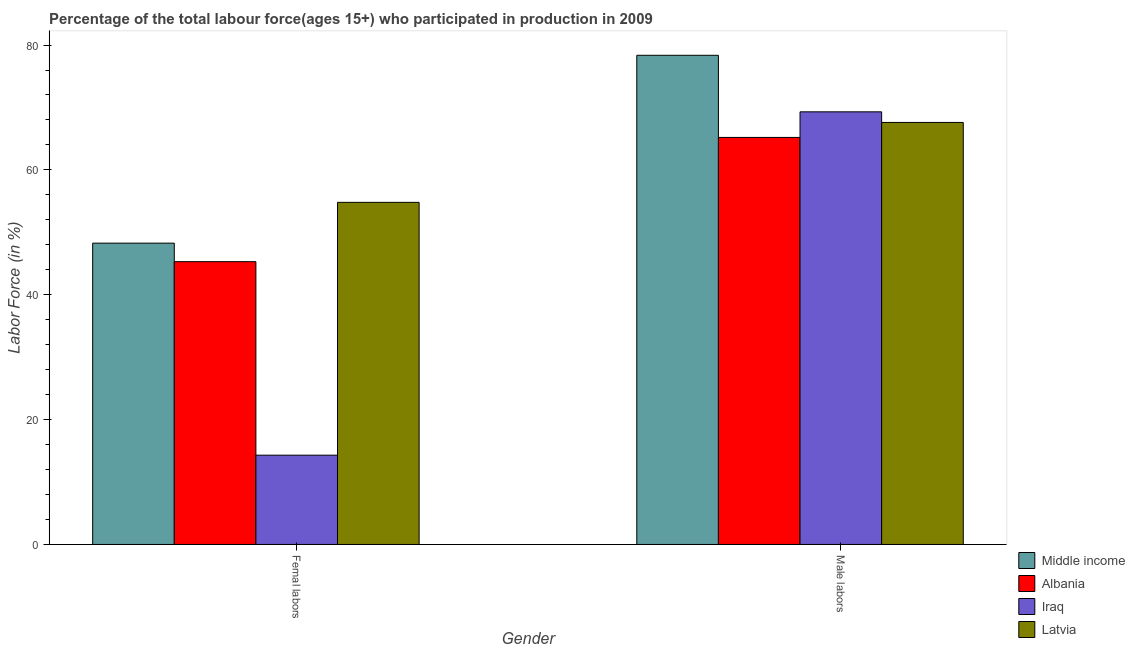How many groups of bars are there?
Give a very brief answer. 2. Are the number of bars per tick equal to the number of legend labels?
Your response must be concise. Yes. Are the number of bars on each tick of the X-axis equal?
Ensure brevity in your answer.  Yes. How many bars are there on the 2nd tick from the left?
Your answer should be very brief. 4. What is the label of the 1st group of bars from the left?
Provide a succinct answer. Femal labors. What is the percentage of female labor force in Albania?
Your answer should be compact. 45.3. Across all countries, what is the maximum percentage of female labor force?
Your response must be concise. 54.8. Across all countries, what is the minimum percentage of female labor force?
Your answer should be compact. 14.3. In which country was the percentage of female labor force maximum?
Provide a succinct answer. Latvia. In which country was the percentage of male labour force minimum?
Your response must be concise. Albania. What is the total percentage of female labor force in the graph?
Your response must be concise. 162.67. What is the difference between the percentage of male labour force in Albania and the percentage of female labor force in Iraq?
Provide a short and direct response. 50.9. What is the average percentage of female labor force per country?
Your answer should be compact. 40.67. What is the difference between the percentage of male labour force and percentage of female labor force in Latvia?
Offer a very short reply. 12.8. What is the ratio of the percentage of male labour force in Albania to that in Latvia?
Keep it short and to the point. 0.96. Is the percentage of male labour force in Albania less than that in Iraq?
Offer a very short reply. Yes. In how many countries, is the percentage of female labor force greater than the average percentage of female labor force taken over all countries?
Offer a terse response. 3. What does the 2nd bar from the left in Femal labors represents?
Offer a terse response. Albania. What does the 2nd bar from the right in Male labors represents?
Offer a very short reply. Iraq. How many bars are there?
Make the answer very short. 8. Does the graph contain grids?
Your answer should be compact. No. What is the title of the graph?
Provide a succinct answer. Percentage of the total labour force(ages 15+) who participated in production in 2009. What is the label or title of the X-axis?
Make the answer very short. Gender. What is the Labor Force (in %) in Middle income in Femal labors?
Your response must be concise. 48.27. What is the Labor Force (in %) of Albania in Femal labors?
Your answer should be very brief. 45.3. What is the Labor Force (in %) in Iraq in Femal labors?
Provide a short and direct response. 14.3. What is the Labor Force (in %) in Latvia in Femal labors?
Offer a very short reply. 54.8. What is the Labor Force (in %) in Middle income in Male labors?
Make the answer very short. 78.36. What is the Labor Force (in %) of Albania in Male labors?
Ensure brevity in your answer.  65.2. What is the Labor Force (in %) of Iraq in Male labors?
Make the answer very short. 69.3. What is the Labor Force (in %) of Latvia in Male labors?
Provide a succinct answer. 67.6. Across all Gender, what is the maximum Labor Force (in %) of Middle income?
Give a very brief answer. 78.36. Across all Gender, what is the maximum Labor Force (in %) of Albania?
Your answer should be compact. 65.2. Across all Gender, what is the maximum Labor Force (in %) in Iraq?
Your answer should be very brief. 69.3. Across all Gender, what is the maximum Labor Force (in %) of Latvia?
Keep it short and to the point. 67.6. Across all Gender, what is the minimum Labor Force (in %) in Middle income?
Offer a terse response. 48.27. Across all Gender, what is the minimum Labor Force (in %) of Albania?
Your response must be concise. 45.3. Across all Gender, what is the minimum Labor Force (in %) of Iraq?
Your answer should be very brief. 14.3. Across all Gender, what is the minimum Labor Force (in %) of Latvia?
Your answer should be compact. 54.8. What is the total Labor Force (in %) in Middle income in the graph?
Your answer should be very brief. 126.63. What is the total Labor Force (in %) of Albania in the graph?
Offer a terse response. 110.5. What is the total Labor Force (in %) of Iraq in the graph?
Your answer should be compact. 83.6. What is the total Labor Force (in %) of Latvia in the graph?
Keep it short and to the point. 122.4. What is the difference between the Labor Force (in %) in Middle income in Femal labors and that in Male labors?
Your answer should be compact. -30.09. What is the difference between the Labor Force (in %) of Albania in Femal labors and that in Male labors?
Your answer should be compact. -19.9. What is the difference between the Labor Force (in %) of Iraq in Femal labors and that in Male labors?
Ensure brevity in your answer.  -55. What is the difference between the Labor Force (in %) in Middle income in Femal labors and the Labor Force (in %) in Albania in Male labors?
Provide a succinct answer. -16.93. What is the difference between the Labor Force (in %) of Middle income in Femal labors and the Labor Force (in %) of Iraq in Male labors?
Make the answer very short. -21.03. What is the difference between the Labor Force (in %) in Middle income in Femal labors and the Labor Force (in %) in Latvia in Male labors?
Provide a short and direct response. -19.33. What is the difference between the Labor Force (in %) in Albania in Femal labors and the Labor Force (in %) in Iraq in Male labors?
Make the answer very short. -24. What is the difference between the Labor Force (in %) in Albania in Femal labors and the Labor Force (in %) in Latvia in Male labors?
Keep it short and to the point. -22.3. What is the difference between the Labor Force (in %) of Iraq in Femal labors and the Labor Force (in %) of Latvia in Male labors?
Your answer should be very brief. -53.3. What is the average Labor Force (in %) of Middle income per Gender?
Make the answer very short. 63.31. What is the average Labor Force (in %) in Albania per Gender?
Keep it short and to the point. 55.25. What is the average Labor Force (in %) of Iraq per Gender?
Your answer should be compact. 41.8. What is the average Labor Force (in %) in Latvia per Gender?
Make the answer very short. 61.2. What is the difference between the Labor Force (in %) in Middle income and Labor Force (in %) in Albania in Femal labors?
Offer a very short reply. 2.97. What is the difference between the Labor Force (in %) in Middle income and Labor Force (in %) in Iraq in Femal labors?
Offer a terse response. 33.97. What is the difference between the Labor Force (in %) in Middle income and Labor Force (in %) in Latvia in Femal labors?
Offer a terse response. -6.53. What is the difference between the Labor Force (in %) of Iraq and Labor Force (in %) of Latvia in Femal labors?
Offer a terse response. -40.5. What is the difference between the Labor Force (in %) in Middle income and Labor Force (in %) in Albania in Male labors?
Keep it short and to the point. 13.16. What is the difference between the Labor Force (in %) of Middle income and Labor Force (in %) of Iraq in Male labors?
Your answer should be very brief. 9.06. What is the difference between the Labor Force (in %) of Middle income and Labor Force (in %) of Latvia in Male labors?
Your answer should be very brief. 10.76. What is the ratio of the Labor Force (in %) in Middle income in Femal labors to that in Male labors?
Give a very brief answer. 0.62. What is the ratio of the Labor Force (in %) in Albania in Femal labors to that in Male labors?
Offer a terse response. 0.69. What is the ratio of the Labor Force (in %) in Iraq in Femal labors to that in Male labors?
Offer a very short reply. 0.21. What is the ratio of the Labor Force (in %) of Latvia in Femal labors to that in Male labors?
Provide a succinct answer. 0.81. What is the difference between the highest and the second highest Labor Force (in %) of Middle income?
Ensure brevity in your answer.  30.09. What is the difference between the highest and the lowest Labor Force (in %) of Middle income?
Ensure brevity in your answer.  30.09. What is the difference between the highest and the lowest Labor Force (in %) of Albania?
Ensure brevity in your answer.  19.9. 